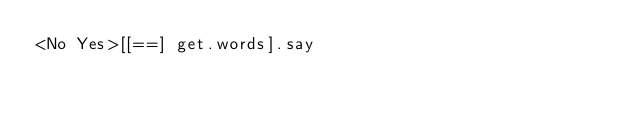Convert code to text. <code><loc_0><loc_0><loc_500><loc_500><_Perl_><No Yes>[[==] get.words].say</code> 